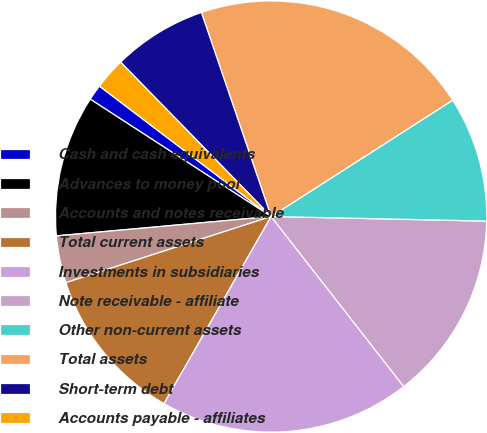Convert chart. <chart><loc_0><loc_0><loc_500><loc_500><pie_chart><fcel>Cash and cash equivalents<fcel>Advances to money pool<fcel>Accounts and notes receivable<fcel>Total current assets<fcel>Investments in subsidiaries<fcel>Note receivable - affiliate<fcel>Other non-current assets<fcel>Total assets<fcel>Short-term debt<fcel>Accounts payable - affiliates<nl><fcel>1.18%<fcel>10.59%<fcel>3.53%<fcel>11.76%<fcel>18.82%<fcel>14.12%<fcel>9.41%<fcel>21.17%<fcel>7.06%<fcel>2.36%<nl></chart> 